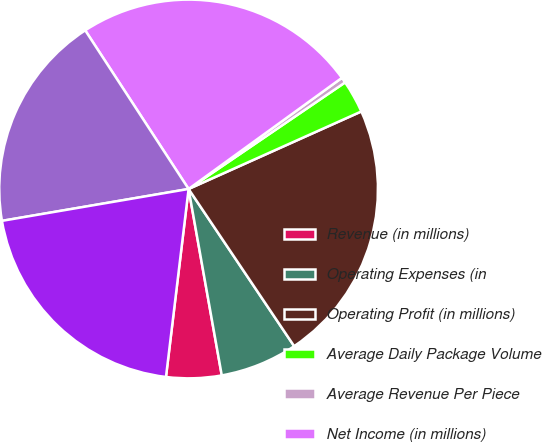Convert chart. <chart><loc_0><loc_0><loc_500><loc_500><pie_chart><fcel>Revenue (in millions)<fcel>Operating Expenses (in<fcel>Operating Profit (in millions)<fcel>Average Daily Package Volume<fcel>Average Revenue Per Piece<fcel>Net Income (in millions)<fcel>Basic Earnings Per Share<fcel>Diluted Earnings Per Share<nl><fcel>4.71%<fcel>6.61%<fcel>22.3%<fcel>2.8%<fcel>0.47%<fcel>24.21%<fcel>18.5%<fcel>20.4%<nl></chart> 